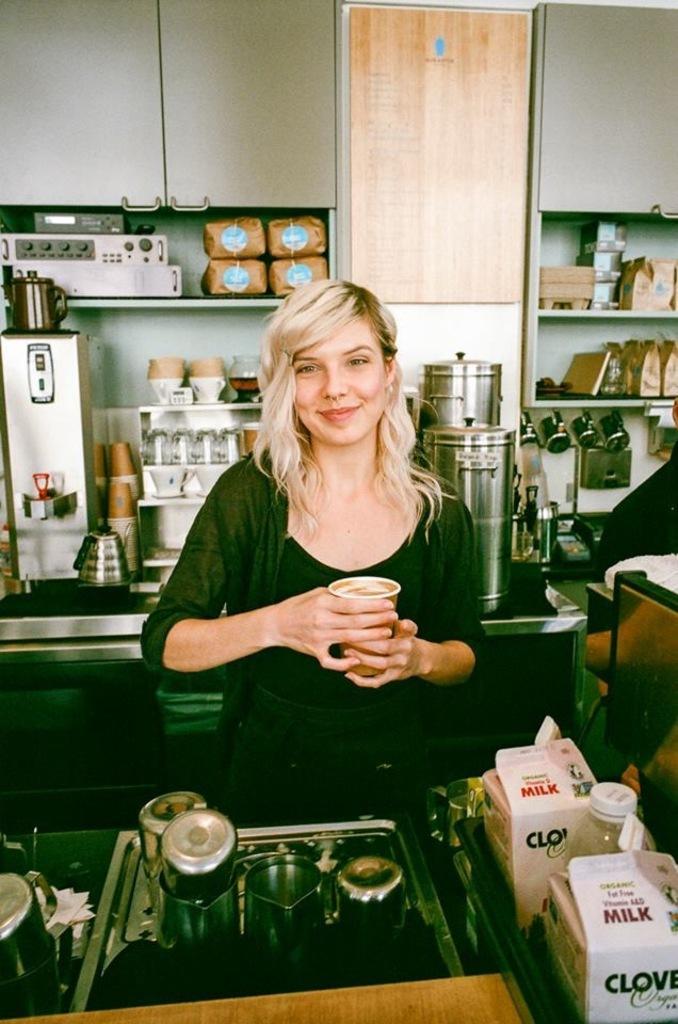Describe this image in one or two sentences. In this image i can see a woman wearing black color dress and holding coffee glass in her hands and at the foreground of the image there is a milk bottle and at the background of the image there are kitchenware. 